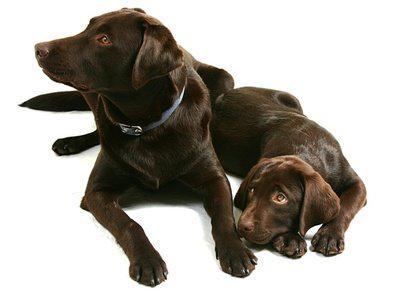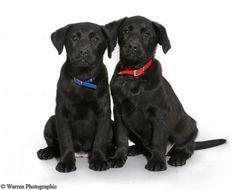The first image is the image on the left, the second image is the image on the right. Evaluate the accuracy of this statement regarding the images: "Two dogs are sitting and two dogs are lying down.". Is it true? Answer yes or no. Yes. The first image is the image on the left, the second image is the image on the right. Assess this claim about the two images: "none of the dogs in the image pair have collars on". Correct or not? Answer yes or no. No. 